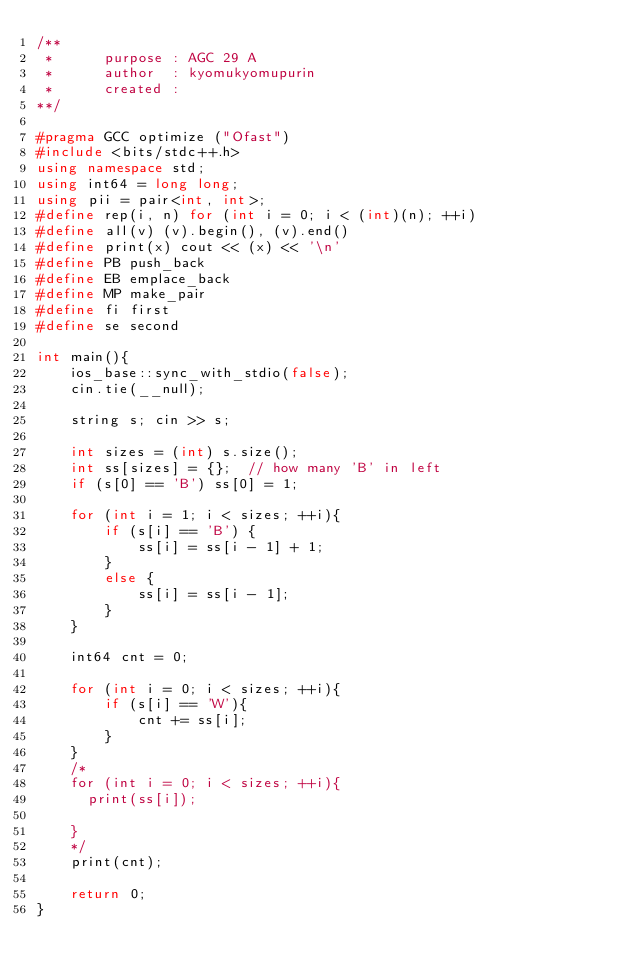Convert code to text. <code><loc_0><loc_0><loc_500><loc_500><_C++_>/**
 *      purpose : AGC 29 A
 *      author  : kyomukyomupurin
 *      created : 
**/

#pragma GCC optimize ("Ofast")
#include <bits/stdc++.h>
using namespace std;
using int64 = long long;
using pii = pair<int, int>;
#define rep(i, n) for (int i = 0; i < (int)(n); ++i)
#define all(v) (v).begin(), (v).end()
#define print(x) cout << (x) << '\n'
#define PB push_back
#define EB emplace_back
#define MP make_pair
#define fi first
#define se second

int main(){
    ios_base::sync_with_stdio(false);
    cin.tie(__null);
    
    string s; cin >> s;

    int sizes = (int) s.size();
    int ss[sizes] = {};  // how many 'B' in left
    if (s[0] == 'B') ss[0] = 1;

    for (int i = 1; i < sizes; ++i){
        if (s[i] == 'B') {
            ss[i] = ss[i - 1] + 1;
        }
        else {
            ss[i] = ss[i - 1];
        }
    }

    int64 cnt = 0;

    for (int i = 0; i < sizes; ++i){
        if (s[i] == 'W'){
            cnt += ss[i];
        }
    }
    /*
    for (int i = 0; i < sizes; ++i){
      print(ss[i]);
    
    }
    */
    print(cnt);
    
    return 0;
}</code> 